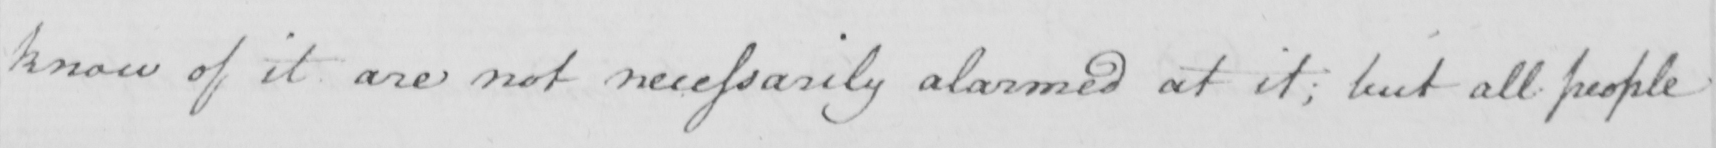What does this handwritten line say? know of it are not necessarily alarmed at it ; but all people 